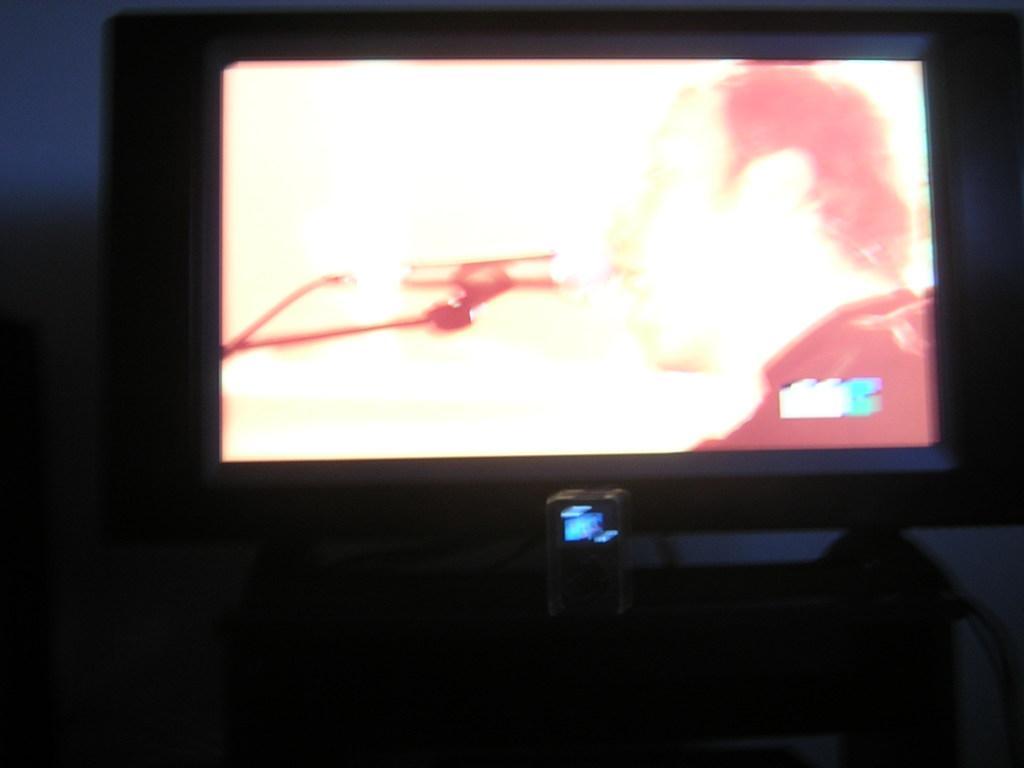How would you summarize this image in a sentence or two? In this image I can see the screen on the table. In the screen I can see the person. And there is a blue background. 